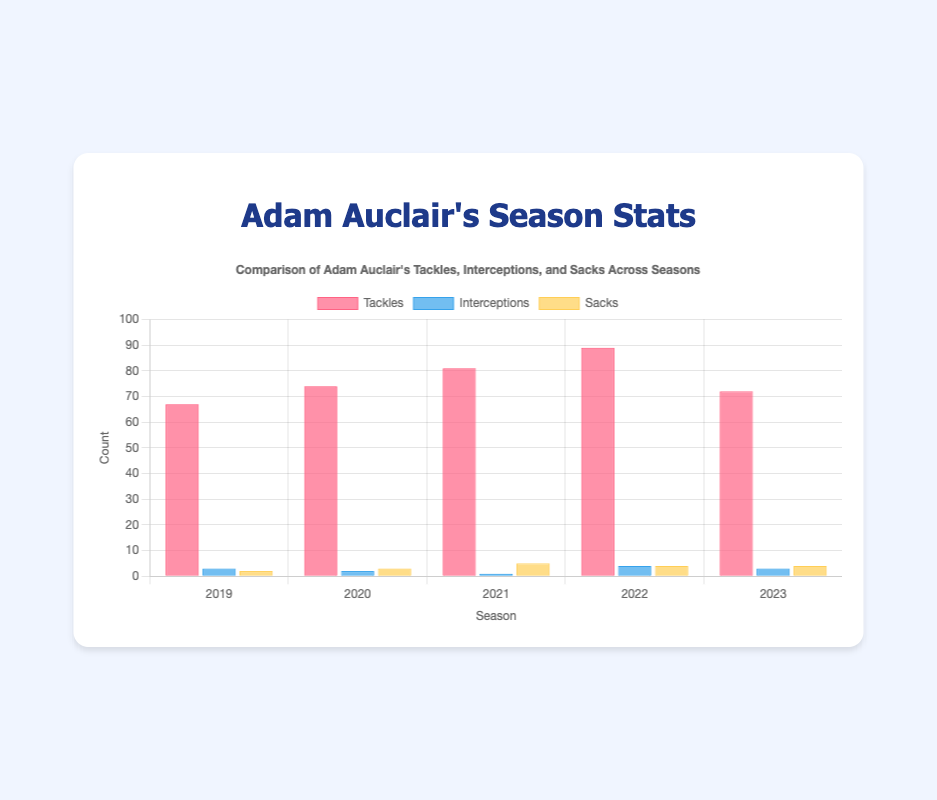What season had the highest number of tackles for Adam Auclair? By observing the heights of the bars for tackles, the tallest bar represents the highest number of tackles. In this case, the 2022 season has the highest bar for tackles.
Answer: 2022 How many more sacks did Adam Auclair have in 2021 compared to 2019? By comparing the height of the sacks bar for 2021 and 2019, we can see that in 2021 he had 5 sacks, and in 2019, he had 2 sacks. Therefore, the difference is 5 - 2 = 3.
Answer: 3 What is the average number of interceptions per season across all seasons shown? The number of interceptions for each season is 3, 2, 1, 4, and 3. To find the average, sum these values and divide by the number of seasons: (3 + 2 + 1 + 4 + 3) / 5 = 13 / 5 = 2.6
Answer: 2.6 Which season had the same number of interceptions as the 2019 season? First, identify the height of the interceptions bar for 2019, which is 3. Then, check for other seasons with the same height in the interceptions bars. The 2023 season also has 3 interceptions.
Answer: 2023 What is the total number of sacks Adam Auclair had across all seasons? Sum the sacks for each season: 2 (2019) + 3 (2020) + 5 (2021) + 4 (2022) + 4 (2023) = 18
Answer: 18 How does the number of tackles in 2020 compare to 2021? Check the heights of the tackles bars for 2020 and 2021. In 2020, there are 74 tackles, and in 2021, there are 81 tackles. 81 is greater than 74.
Answer: 2021 had more tackles Which statistic saw the largest increase from 2019 to 2020? Compare the differences for tackles, interceptions, and sacks from 2019 to 2020. Tackles increased from 67 to 74 (+7), interceptions decreased from 3 to 2 (-1), sacks increased from 2 to 3 (+1). The largest increase is in tackles.
Answer: Tackles What color represents the interceptions bars in the chart? By looking at the legend in the chart, the interceptions bars are represented in blue color.
Answer: Blue In which season did Adam Auclair achieve his highest number of sacks? Identify the tallest bar in the sacks category. The highest value is associated with the 2021 season, where there are 5 sacks.
Answer: 2021 